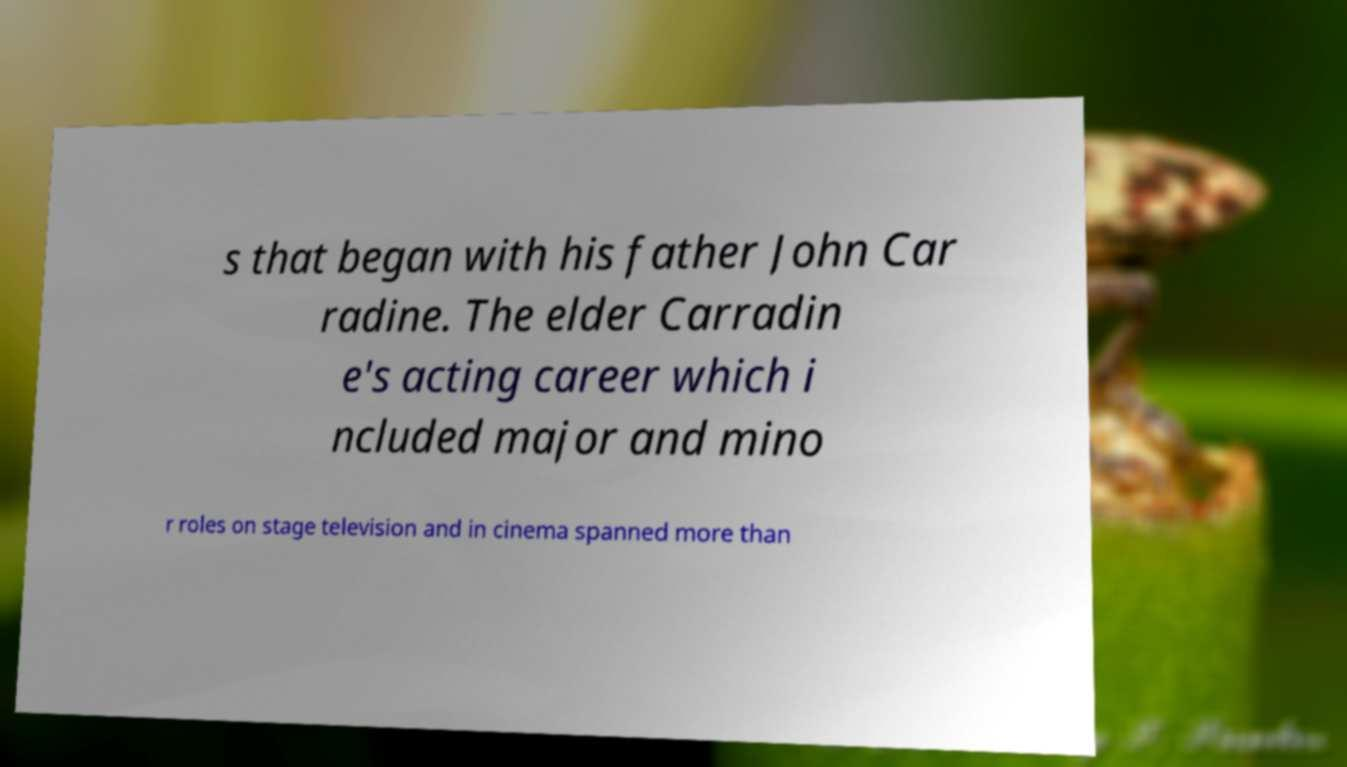Please read and relay the text visible in this image. What does it say? s that began with his father John Car radine. The elder Carradin e's acting career which i ncluded major and mino r roles on stage television and in cinema spanned more than 